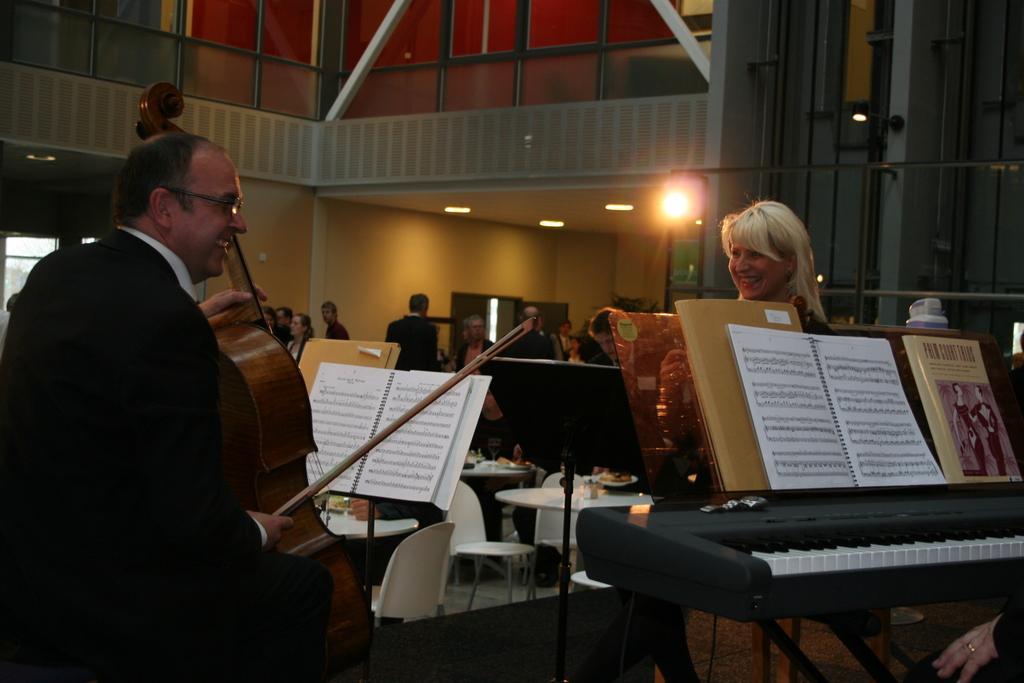How would you summarize this image in a sentence or two? This is a picture taken in a room. The man in black blazer playing a music instrument in front of the man there is a woman is also looking into a book. Background of the woman is wall with lights. 